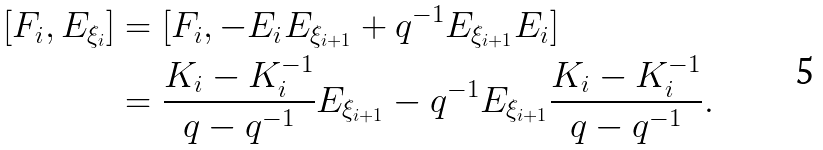<formula> <loc_0><loc_0><loc_500><loc_500>[ F _ { i } , E _ { \xi _ { i } } ] & = [ F _ { i } , - E _ { i } E _ { \xi _ { i + 1 } } + q ^ { - 1 } E _ { \xi _ { i + 1 } } E _ { i } ] \\ & = \frac { K _ { i } - K _ { i } ^ { - 1 } } { q - q ^ { - 1 } } E _ { \xi _ { i + 1 } } - q ^ { - 1 } E _ { \xi _ { i + 1 } } \frac { K _ { i } - K _ { i } ^ { - 1 } } { q - q ^ { - 1 } } .</formula> 